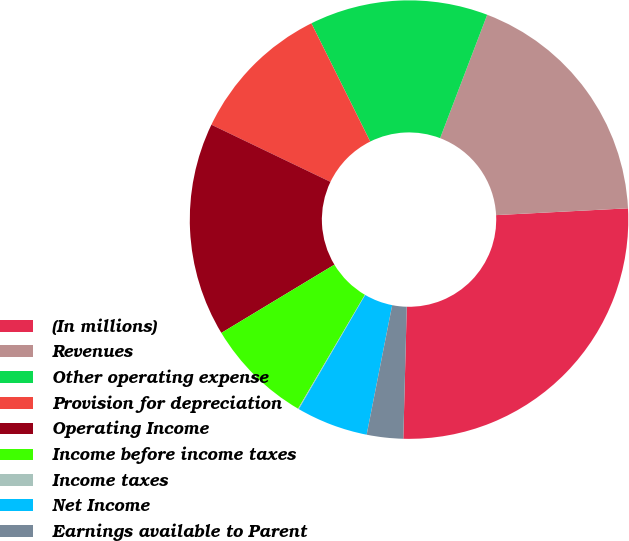Convert chart to OTSL. <chart><loc_0><loc_0><loc_500><loc_500><pie_chart><fcel>(In millions)<fcel>Revenues<fcel>Other operating expense<fcel>Provision for depreciation<fcel>Operating Income<fcel>Income before income taxes<fcel>Income taxes<fcel>Net Income<fcel>Earnings available to Parent<nl><fcel>26.24%<fcel>18.38%<fcel>13.15%<fcel>10.53%<fcel>15.77%<fcel>7.91%<fcel>0.06%<fcel>5.29%<fcel>2.68%<nl></chart> 